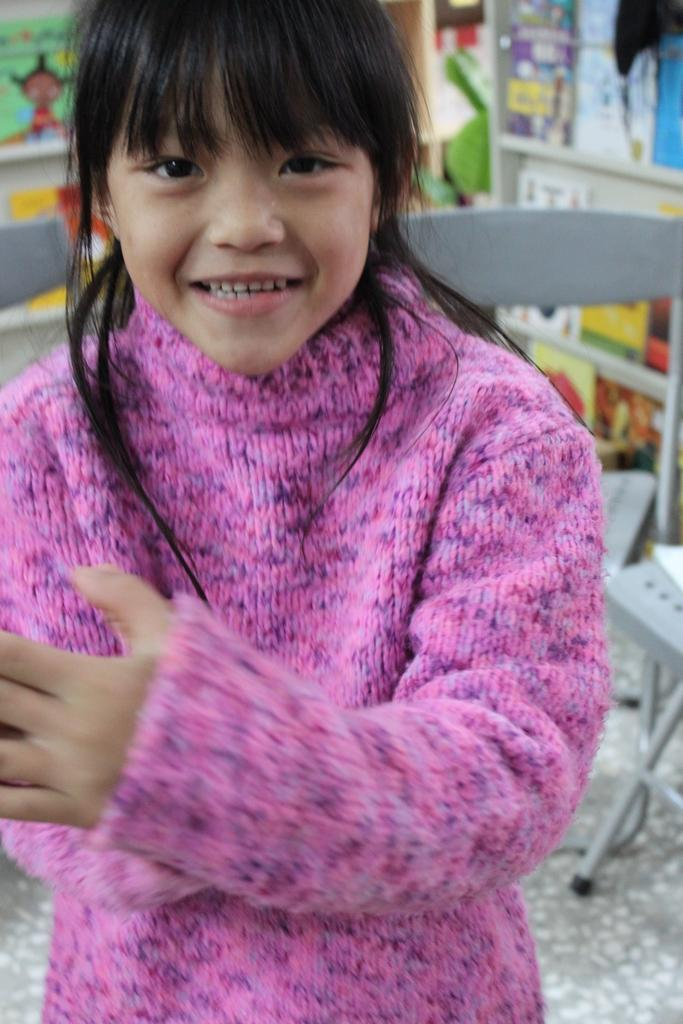Who is the main subject in the image? There is a girl in the image. What is the girl wearing? The girl is wearing a pink dress. What can be seen in the background of the image? There are chairs and a shelf with objects in the background of the image. What is visible at the bottom of the image? There is a floor visible at the bottom of the image. Can you see any ducks in space in the image? There are no ducks or space present in the image; it features a girl wearing a pink dress in a setting with chairs, a shelf, and a floor. 